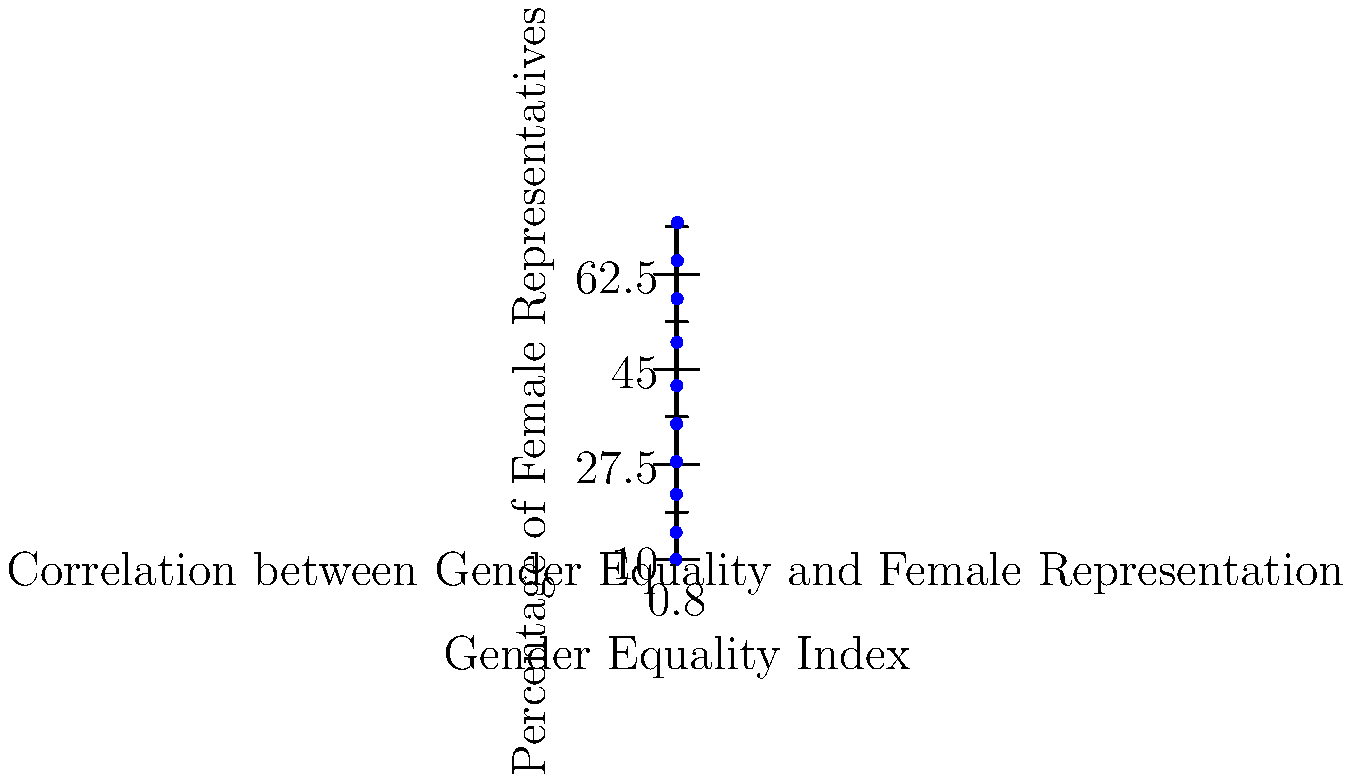Based on the scatter plot showing the relationship between a state's gender equality index and the percentage of female representatives, what can be inferred about the correlation between these two variables? To analyze the correlation between a state's gender equality index and the percentage of female representatives, we need to examine the scatter plot:

1. Direction: The points generally move from the bottom-left to the top-right of the graph. This indicates a positive correlation.

2. Strength: The points form a relatively tight pattern around an imaginary line, suggesting a strong correlation.

3. Linearity: The relationship appears to be approximately linear, as the points roughly follow a straight line.

4. Outliers: There don't appear to be any significant outliers that deviate from the general trend.

5. Range: The gender equality index ranges from about 0.65 to 0.93, while the percentage of female representatives ranges from about 10% to 72%.

6. Slope: The line of best fit (if drawn) would have a positive slope, further confirming the positive correlation.

7. Interpretation: As the gender equality index increases, there is a clear trend of an increase in the percentage of female representatives.

Given these observations, we can conclude that there is a strong positive correlation between a state's gender equality index and its likelihood of electing female representatives.
Answer: Strong positive correlation 